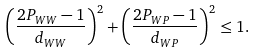<formula> <loc_0><loc_0><loc_500><loc_500>\left ( \frac { 2 P _ { W W } - 1 } { d _ { W W } } \right ) ^ { 2 } + \left ( \frac { 2 P _ { W P } - 1 } { d _ { W P } } \right ) ^ { 2 } \leq 1 .</formula> 